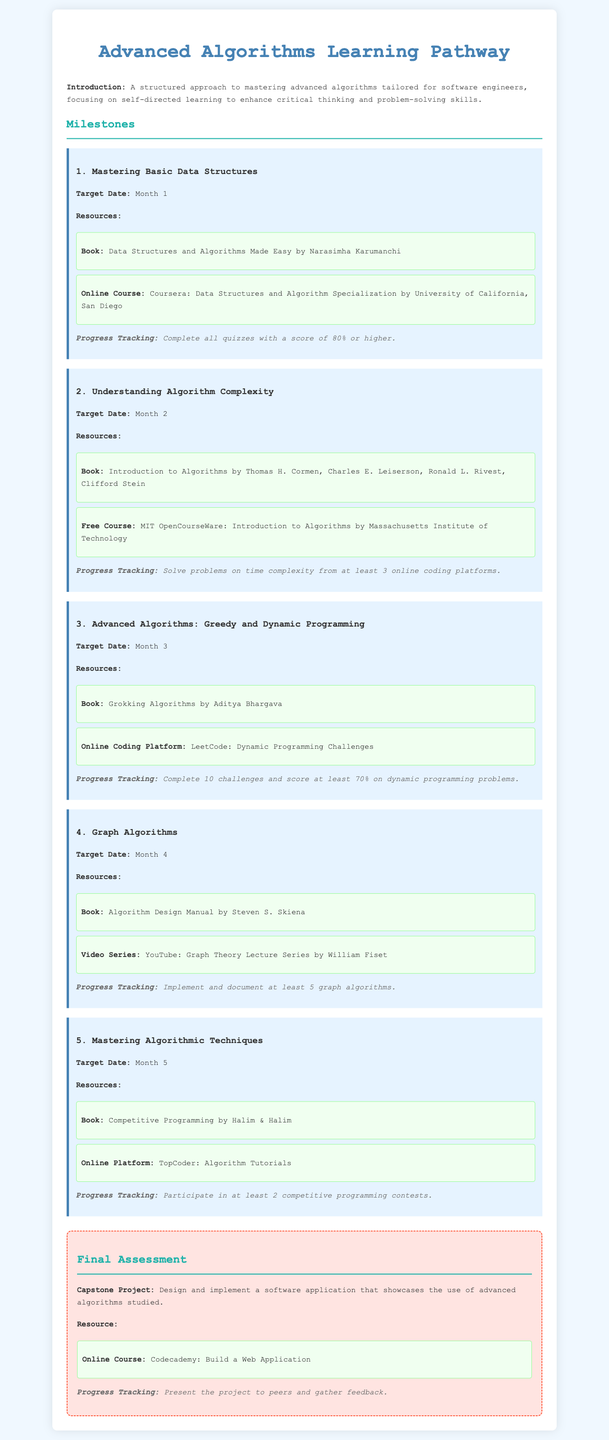what is the target date for mastering basic data structures? The target date is specified in the milestone section of the document, which is Month 1.
Answer: Month 1 what book is recommended for understanding algorithm complexity? The document lists recommended resources for each milestone, including books. For understanding algorithm complexity, the book is "Introduction to Algorithms".
Answer: Introduction to Algorithms how many challenges must be completed for the advanced algorithms milestone? The milestone specifies a requirement for completing challenges as part of the progress tracking. The number required is 10 challenges.
Answer: 10 challenges what is the final assessment project? The final assessment section contains a description of the capstone project that should be completed at the end of the learning pathway. The project involves designing and implementing a software application.
Answer: Design and implement a software application which online platform is recommended for mastering algorithmic techniques? The resources section for mastering algorithmic techniques specifies an online platform. The platform mentioned is TopCoder.
Answer: TopCoder how long is the entire learning pathway planned for? Each milestone has a target date, which indicates the duration of each phase. The total time across milestones is 5 months.
Answer: 5 months what is the resource used for the final assessment? The document specifies resources for the final assessment, including an online course. The mentioned course is Codecademy: Build a Web Application.
Answer: Codecademy: Build a Web Application what must be documented for the graph algorithms milestone? The progress tracking part of this milestone requires implementation and documentation of specific algorithms. The number mentioned is at least 5 graph algorithms.
Answer: 5 graph algorithms 